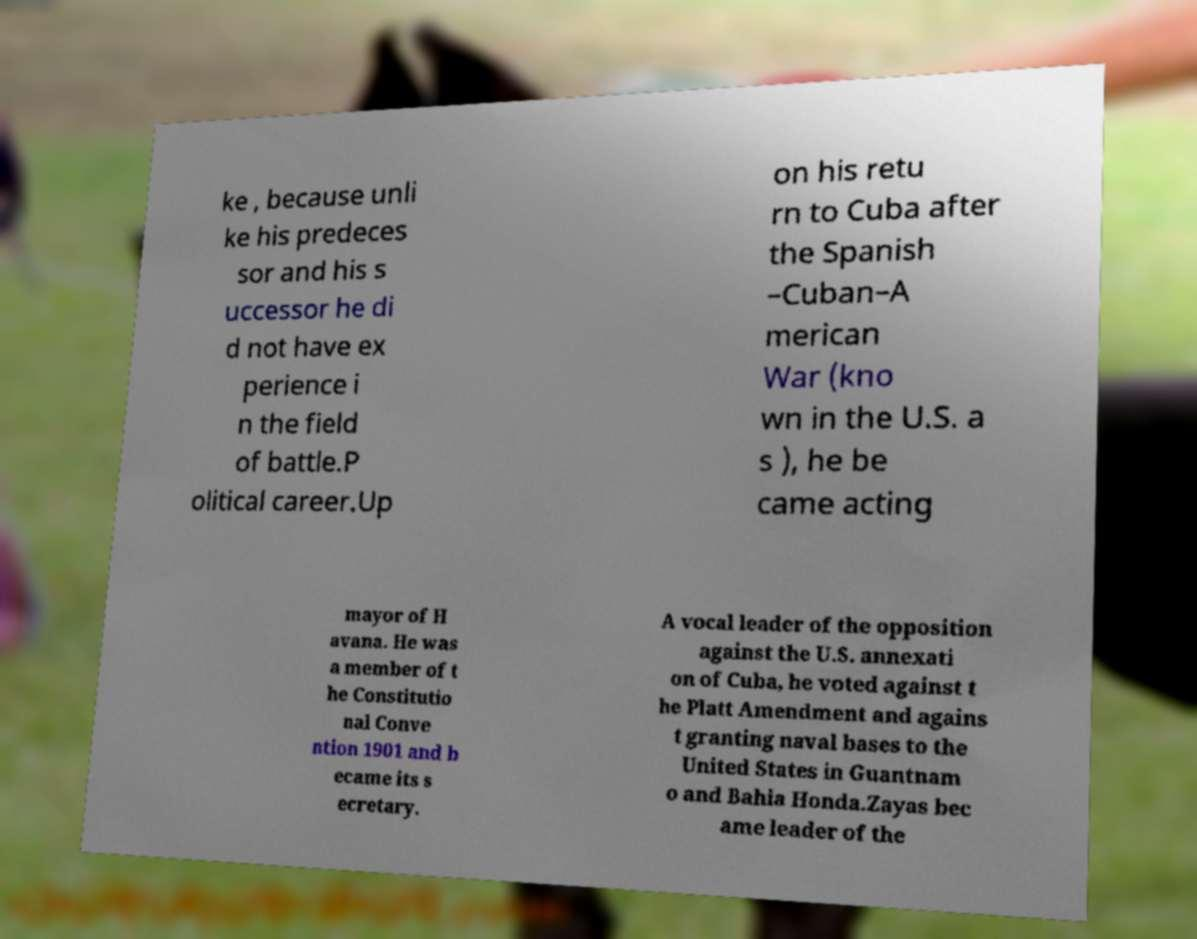Can you read and provide the text displayed in the image?This photo seems to have some interesting text. Can you extract and type it out for me? ke , because unli ke his predeces sor and his s uccessor he di d not have ex perience i n the field of battle.P olitical career.Up on his retu rn to Cuba after the Spanish –Cuban–A merican War (kno wn in the U.S. a s ), he be came acting mayor of H avana. He was a member of t he Constitutio nal Conve ntion 1901 and b ecame its s ecretary. A vocal leader of the opposition against the U.S. annexati on of Cuba, he voted against t he Platt Amendment and agains t granting naval bases to the United States in Guantnam o and Bahia Honda.Zayas bec ame leader of the 